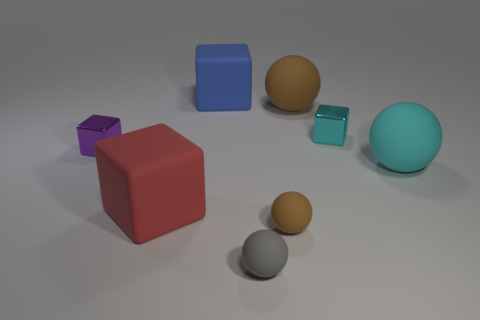There is another brown thing that is the same shape as the big brown object; what is its material?
Provide a succinct answer. Rubber. What color is the shiny block to the right of the small sphere right of the small gray ball?
Keep it short and to the point. Cyan. There is a big matte ball that is behind the tiny metallic thing behind the purple metal object; what number of gray matte spheres are behind it?
Your answer should be compact. 0. There is a tiny purple thing; are there any large rubber things in front of it?
Your answer should be compact. Yes. How many cubes are brown matte objects or red things?
Your response must be concise. 1. How many big things are on the right side of the large blue rubber thing and in front of the purple thing?
Give a very brief answer. 1. Are there the same number of tiny purple things that are behind the large blue object and large red rubber blocks that are left of the small purple shiny thing?
Provide a succinct answer. Yes. There is a cyan object behind the small purple metallic object; is it the same shape as the large red matte object?
Your answer should be very brief. Yes. There is a tiny object that is behind the tiny metal block left of the tiny shiny block that is on the right side of the big blue thing; what is its shape?
Give a very brief answer. Cube. There is a big thing that is in front of the purple shiny cube and left of the tiny gray thing; what material is it made of?
Offer a terse response. Rubber. 